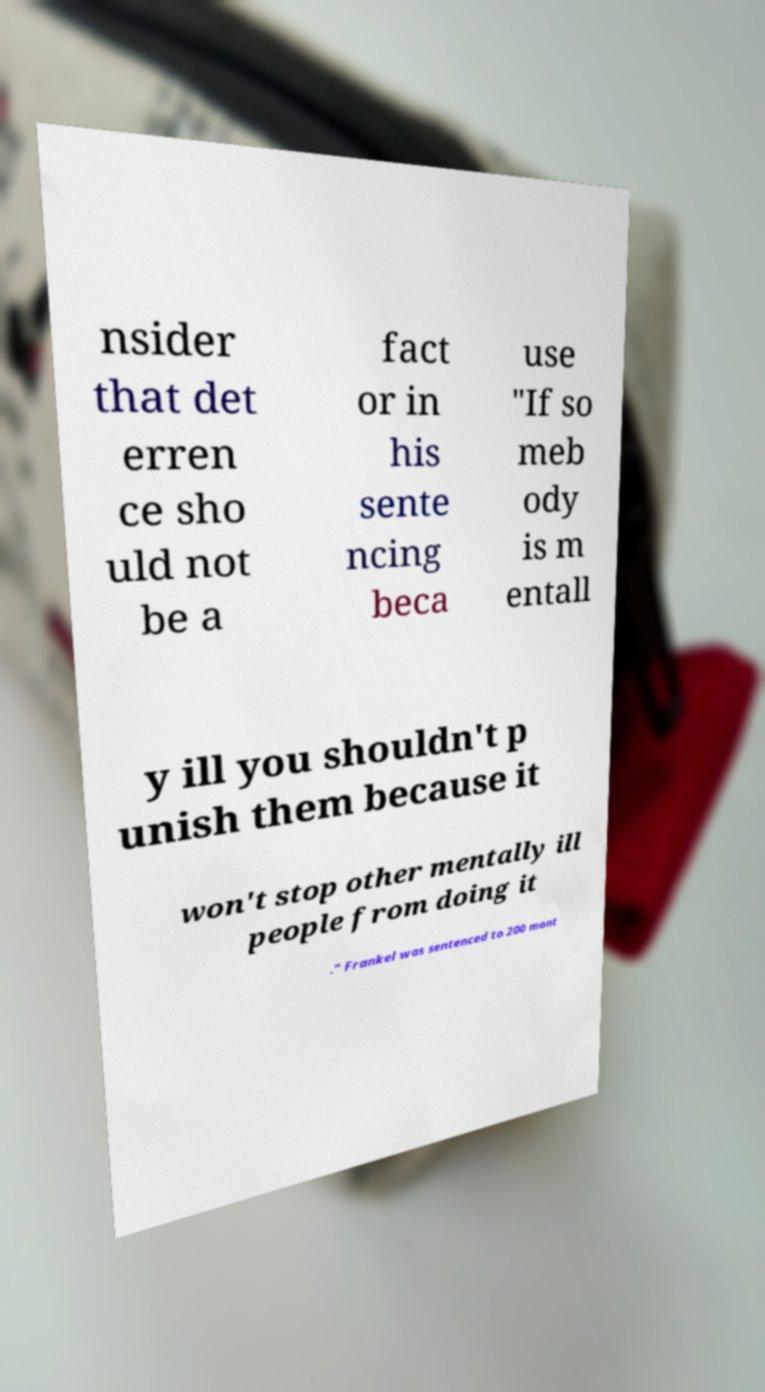Could you extract and type out the text from this image? nsider that det erren ce sho uld not be a fact or in his sente ncing beca use "If so meb ody is m entall y ill you shouldn't p unish them because it won't stop other mentally ill people from doing it ." Frankel was sentenced to 200 mont 